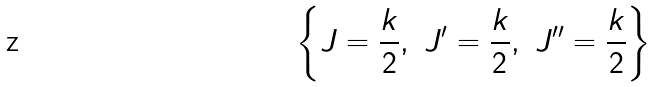<formula> <loc_0><loc_0><loc_500><loc_500>\left \{ J = \frac { k } { 2 } , \ J ^ { \prime } = \frac { k } { 2 } , \ J ^ { \prime \prime } = \frac { k } { 2 } \right \}</formula> 